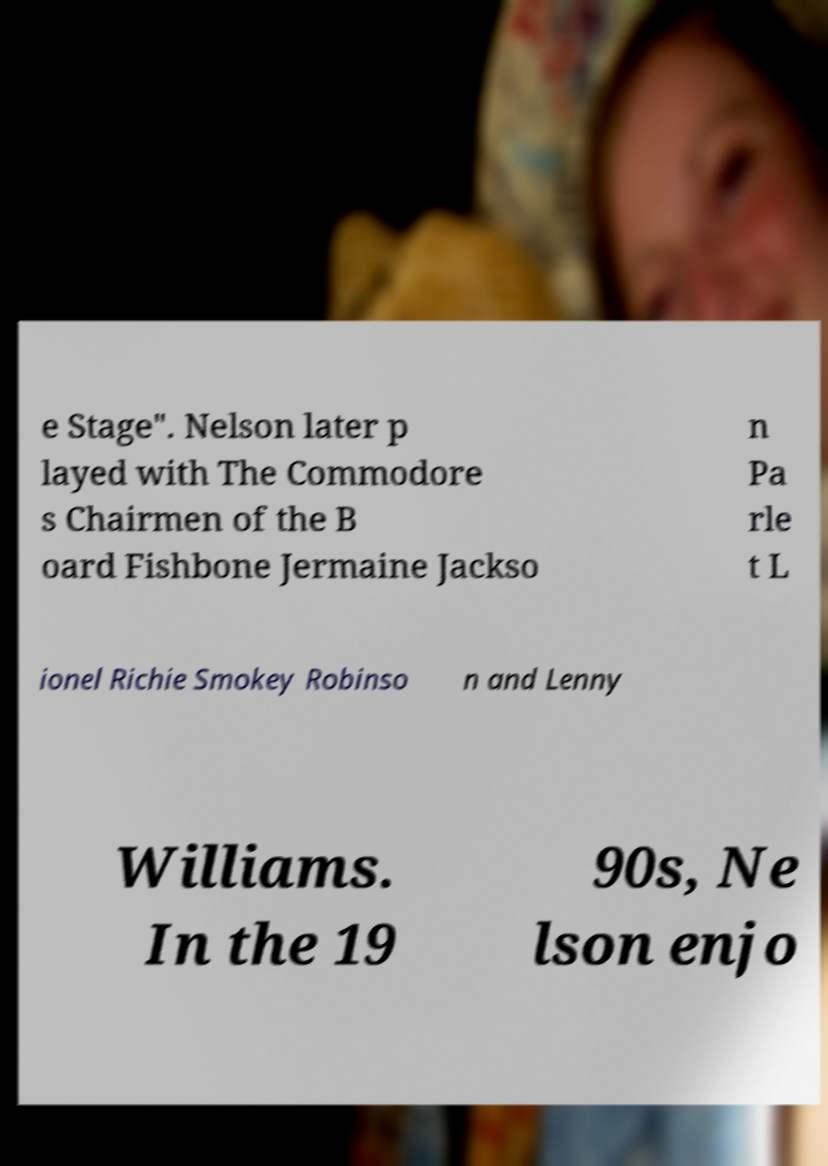Please read and relay the text visible in this image. What does it say? e Stage". Nelson later p layed with The Commodore s Chairmen of the B oard Fishbone Jermaine Jackso n Pa rle t L ionel Richie Smokey Robinso n and Lenny Williams. In the 19 90s, Ne lson enjo 